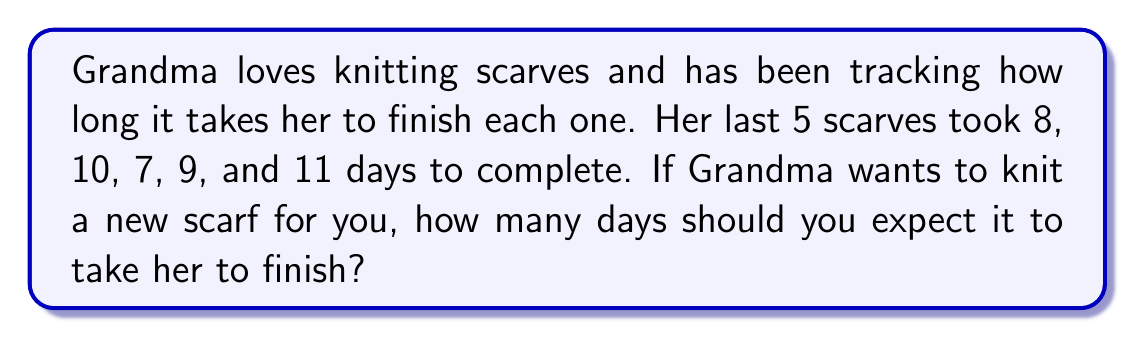Teach me how to tackle this problem. To estimate how long it will take Grandma to knit a new scarf, we can use the average (mean) of her past knitting times. This is a simple way to make a prediction based on past data.

Let's follow these steps:

1. List the number of days for each scarf:
   8, 10, 7, 9, 11 days

2. Calculate the sum of all the days:
   $8 + 10 + 7 + 9 + 11 = 45$ days

3. Count the total number of scarves:
   There are 5 scarves in total.

4. Calculate the average (mean) time:
   $$\text{Average} = \frac{\text{Sum of all days}}{\text{Number of scarves}}$$
   $$\text{Average} = \frac{45}{5} = 9\text{ days}$$

Therefore, based on Grandma's past knitting data, we can estimate that it will take her about 9 days to complete a new scarf for you.
Answer: 9 days 